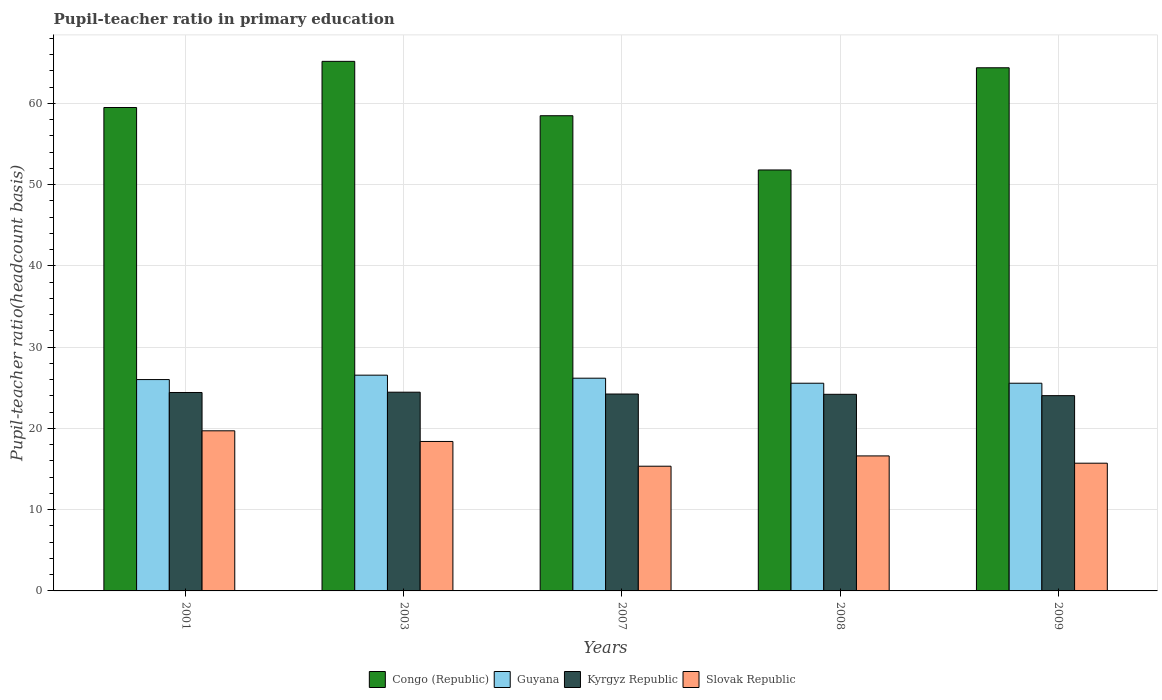Are the number of bars per tick equal to the number of legend labels?
Provide a succinct answer. Yes. In how many cases, is the number of bars for a given year not equal to the number of legend labels?
Your answer should be compact. 0. What is the pupil-teacher ratio in primary education in Guyana in 2001?
Make the answer very short. 26.01. Across all years, what is the maximum pupil-teacher ratio in primary education in Kyrgyz Republic?
Ensure brevity in your answer.  24.46. Across all years, what is the minimum pupil-teacher ratio in primary education in Slovak Republic?
Ensure brevity in your answer.  15.35. In which year was the pupil-teacher ratio in primary education in Congo (Republic) minimum?
Your answer should be compact. 2008. What is the total pupil-teacher ratio in primary education in Slovak Republic in the graph?
Make the answer very short. 85.78. What is the difference between the pupil-teacher ratio in primary education in Slovak Republic in 2003 and that in 2009?
Ensure brevity in your answer.  2.67. What is the difference between the pupil-teacher ratio in primary education in Congo (Republic) in 2008 and the pupil-teacher ratio in primary education in Slovak Republic in 2001?
Your response must be concise. 32.1. What is the average pupil-teacher ratio in primary education in Slovak Republic per year?
Your response must be concise. 17.16. In the year 2003, what is the difference between the pupil-teacher ratio in primary education in Guyana and pupil-teacher ratio in primary education in Kyrgyz Republic?
Keep it short and to the point. 2.1. What is the ratio of the pupil-teacher ratio in primary education in Guyana in 2007 to that in 2009?
Offer a very short reply. 1.02. Is the pupil-teacher ratio in primary education in Congo (Republic) in 2001 less than that in 2007?
Your response must be concise. No. What is the difference between the highest and the second highest pupil-teacher ratio in primary education in Kyrgyz Republic?
Your answer should be compact. 0.04. What is the difference between the highest and the lowest pupil-teacher ratio in primary education in Congo (Republic)?
Make the answer very short. 13.37. In how many years, is the pupil-teacher ratio in primary education in Congo (Republic) greater than the average pupil-teacher ratio in primary education in Congo (Republic) taken over all years?
Your answer should be compact. 2. Is the sum of the pupil-teacher ratio in primary education in Guyana in 2003 and 2009 greater than the maximum pupil-teacher ratio in primary education in Kyrgyz Republic across all years?
Your answer should be compact. Yes. What does the 4th bar from the left in 2003 represents?
Provide a succinct answer. Slovak Republic. What does the 2nd bar from the right in 2009 represents?
Provide a short and direct response. Kyrgyz Republic. How many bars are there?
Provide a succinct answer. 20. Are all the bars in the graph horizontal?
Ensure brevity in your answer.  No. How many years are there in the graph?
Your answer should be compact. 5. Does the graph contain any zero values?
Your answer should be very brief. No. How many legend labels are there?
Provide a succinct answer. 4. What is the title of the graph?
Provide a short and direct response. Pupil-teacher ratio in primary education. What is the label or title of the X-axis?
Offer a very short reply. Years. What is the label or title of the Y-axis?
Your answer should be very brief. Pupil-teacher ratio(headcount basis). What is the Pupil-teacher ratio(headcount basis) in Congo (Republic) in 2001?
Your answer should be very brief. 59.49. What is the Pupil-teacher ratio(headcount basis) in Guyana in 2001?
Your response must be concise. 26.01. What is the Pupil-teacher ratio(headcount basis) in Kyrgyz Republic in 2001?
Give a very brief answer. 24.42. What is the Pupil-teacher ratio(headcount basis) of Slovak Republic in 2001?
Your answer should be compact. 19.7. What is the Pupil-teacher ratio(headcount basis) in Congo (Republic) in 2003?
Your answer should be compact. 65.17. What is the Pupil-teacher ratio(headcount basis) in Guyana in 2003?
Ensure brevity in your answer.  26.55. What is the Pupil-teacher ratio(headcount basis) of Kyrgyz Republic in 2003?
Your answer should be compact. 24.46. What is the Pupil-teacher ratio(headcount basis) of Slovak Republic in 2003?
Keep it short and to the point. 18.39. What is the Pupil-teacher ratio(headcount basis) in Congo (Republic) in 2007?
Your answer should be compact. 58.48. What is the Pupil-teacher ratio(headcount basis) in Guyana in 2007?
Your response must be concise. 26.18. What is the Pupil-teacher ratio(headcount basis) of Kyrgyz Republic in 2007?
Your answer should be very brief. 24.23. What is the Pupil-teacher ratio(headcount basis) in Slovak Republic in 2007?
Keep it short and to the point. 15.35. What is the Pupil-teacher ratio(headcount basis) in Congo (Republic) in 2008?
Offer a very short reply. 51.8. What is the Pupil-teacher ratio(headcount basis) of Guyana in 2008?
Provide a short and direct response. 25.56. What is the Pupil-teacher ratio(headcount basis) of Kyrgyz Republic in 2008?
Give a very brief answer. 24.2. What is the Pupil-teacher ratio(headcount basis) in Slovak Republic in 2008?
Keep it short and to the point. 16.61. What is the Pupil-teacher ratio(headcount basis) in Congo (Republic) in 2009?
Your response must be concise. 64.38. What is the Pupil-teacher ratio(headcount basis) in Guyana in 2009?
Your response must be concise. 25.56. What is the Pupil-teacher ratio(headcount basis) in Kyrgyz Republic in 2009?
Your answer should be compact. 24.03. What is the Pupil-teacher ratio(headcount basis) in Slovak Republic in 2009?
Make the answer very short. 15.72. Across all years, what is the maximum Pupil-teacher ratio(headcount basis) in Congo (Republic)?
Your response must be concise. 65.17. Across all years, what is the maximum Pupil-teacher ratio(headcount basis) in Guyana?
Give a very brief answer. 26.55. Across all years, what is the maximum Pupil-teacher ratio(headcount basis) of Kyrgyz Republic?
Offer a terse response. 24.46. Across all years, what is the maximum Pupil-teacher ratio(headcount basis) in Slovak Republic?
Ensure brevity in your answer.  19.7. Across all years, what is the minimum Pupil-teacher ratio(headcount basis) in Congo (Republic)?
Keep it short and to the point. 51.8. Across all years, what is the minimum Pupil-teacher ratio(headcount basis) of Guyana?
Give a very brief answer. 25.56. Across all years, what is the minimum Pupil-teacher ratio(headcount basis) in Kyrgyz Republic?
Ensure brevity in your answer.  24.03. Across all years, what is the minimum Pupil-teacher ratio(headcount basis) in Slovak Republic?
Give a very brief answer. 15.35. What is the total Pupil-teacher ratio(headcount basis) of Congo (Republic) in the graph?
Offer a terse response. 299.33. What is the total Pupil-teacher ratio(headcount basis) of Guyana in the graph?
Provide a succinct answer. 129.86. What is the total Pupil-teacher ratio(headcount basis) of Kyrgyz Republic in the graph?
Ensure brevity in your answer.  121.33. What is the total Pupil-teacher ratio(headcount basis) of Slovak Republic in the graph?
Ensure brevity in your answer.  85.78. What is the difference between the Pupil-teacher ratio(headcount basis) of Congo (Republic) in 2001 and that in 2003?
Give a very brief answer. -5.68. What is the difference between the Pupil-teacher ratio(headcount basis) in Guyana in 2001 and that in 2003?
Offer a very short reply. -0.54. What is the difference between the Pupil-teacher ratio(headcount basis) in Kyrgyz Republic in 2001 and that in 2003?
Your response must be concise. -0.04. What is the difference between the Pupil-teacher ratio(headcount basis) of Slovak Republic in 2001 and that in 2003?
Offer a very short reply. 1.31. What is the difference between the Pupil-teacher ratio(headcount basis) of Congo (Republic) in 2001 and that in 2007?
Provide a succinct answer. 1.01. What is the difference between the Pupil-teacher ratio(headcount basis) of Guyana in 2001 and that in 2007?
Provide a short and direct response. -0.17. What is the difference between the Pupil-teacher ratio(headcount basis) in Kyrgyz Republic in 2001 and that in 2007?
Offer a terse response. 0.19. What is the difference between the Pupil-teacher ratio(headcount basis) of Slovak Republic in 2001 and that in 2007?
Make the answer very short. 4.36. What is the difference between the Pupil-teacher ratio(headcount basis) of Congo (Republic) in 2001 and that in 2008?
Ensure brevity in your answer.  7.69. What is the difference between the Pupil-teacher ratio(headcount basis) of Guyana in 2001 and that in 2008?
Your answer should be very brief. 0.45. What is the difference between the Pupil-teacher ratio(headcount basis) in Kyrgyz Republic in 2001 and that in 2008?
Your response must be concise. 0.22. What is the difference between the Pupil-teacher ratio(headcount basis) in Slovak Republic in 2001 and that in 2008?
Make the answer very short. 3.09. What is the difference between the Pupil-teacher ratio(headcount basis) of Congo (Republic) in 2001 and that in 2009?
Keep it short and to the point. -4.89. What is the difference between the Pupil-teacher ratio(headcount basis) of Guyana in 2001 and that in 2009?
Your response must be concise. 0.45. What is the difference between the Pupil-teacher ratio(headcount basis) in Kyrgyz Republic in 2001 and that in 2009?
Your response must be concise. 0.39. What is the difference between the Pupil-teacher ratio(headcount basis) in Slovak Republic in 2001 and that in 2009?
Your answer should be compact. 3.98. What is the difference between the Pupil-teacher ratio(headcount basis) in Congo (Republic) in 2003 and that in 2007?
Provide a succinct answer. 6.69. What is the difference between the Pupil-teacher ratio(headcount basis) in Guyana in 2003 and that in 2007?
Your answer should be very brief. 0.37. What is the difference between the Pupil-teacher ratio(headcount basis) of Kyrgyz Republic in 2003 and that in 2007?
Provide a succinct answer. 0.22. What is the difference between the Pupil-teacher ratio(headcount basis) of Slovak Republic in 2003 and that in 2007?
Make the answer very short. 3.05. What is the difference between the Pupil-teacher ratio(headcount basis) of Congo (Republic) in 2003 and that in 2008?
Provide a succinct answer. 13.37. What is the difference between the Pupil-teacher ratio(headcount basis) of Guyana in 2003 and that in 2008?
Provide a succinct answer. 0.99. What is the difference between the Pupil-teacher ratio(headcount basis) of Kyrgyz Republic in 2003 and that in 2008?
Offer a terse response. 0.26. What is the difference between the Pupil-teacher ratio(headcount basis) of Slovak Republic in 2003 and that in 2008?
Give a very brief answer. 1.78. What is the difference between the Pupil-teacher ratio(headcount basis) in Congo (Republic) in 2003 and that in 2009?
Ensure brevity in your answer.  0.79. What is the difference between the Pupil-teacher ratio(headcount basis) of Guyana in 2003 and that in 2009?
Provide a succinct answer. 0.99. What is the difference between the Pupil-teacher ratio(headcount basis) in Kyrgyz Republic in 2003 and that in 2009?
Your answer should be very brief. 0.42. What is the difference between the Pupil-teacher ratio(headcount basis) of Slovak Republic in 2003 and that in 2009?
Keep it short and to the point. 2.67. What is the difference between the Pupil-teacher ratio(headcount basis) of Congo (Republic) in 2007 and that in 2008?
Your answer should be compact. 6.68. What is the difference between the Pupil-teacher ratio(headcount basis) of Guyana in 2007 and that in 2008?
Keep it short and to the point. 0.62. What is the difference between the Pupil-teacher ratio(headcount basis) in Kyrgyz Republic in 2007 and that in 2008?
Provide a short and direct response. 0.03. What is the difference between the Pupil-teacher ratio(headcount basis) of Slovak Republic in 2007 and that in 2008?
Offer a very short reply. -1.27. What is the difference between the Pupil-teacher ratio(headcount basis) in Congo (Republic) in 2007 and that in 2009?
Offer a very short reply. -5.9. What is the difference between the Pupil-teacher ratio(headcount basis) of Guyana in 2007 and that in 2009?
Offer a very short reply. 0.62. What is the difference between the Pupil-teacher ratio(headcount basis) in Kyrgyz Republic in 2007 and that in 2009?
Provide a short and direct response. 0.2. What is the difference between the Pupil-teacher ratio(headcount basis) in Slovak Republic in 2007 and that in 2009?
Give a very brief answer. -0.37. What is the difference between the Pupil-teacher ratio(headcount basis) in Congo (Republic) in 2008 and that in 2009?
Keep it short and to the point. -12.58. What is the difference between the Pupil-teacher ratio(headcount basis) of Guyana in 2008 and that in 2009?
Provide a succinct answer. -0. What is the difference between the Pupil-teacher ratio(headcount basis) of Kyrgyz Republic in 2008 and that in 2009?
Provide a succinct answer. 0.17. What is the difference between the Pupil-teacher ratio(headcount basis) in Slovak Republic in 2008 and that in 2009?
Offer a terse response. 0.89. What is the difference between the Pupil-teacher ratio(headcount basis) of Congo (Republic) in 2001 and the Pupil-teacher ratio(headcount basis) of Guyana in 2003?
Keep it short and to the point. 32.94. What is the difference between the Pupil-teacher ratio(headcount basis) of Congo (Republic) in 2001 and the Pupil-teacher ratio(headcount basis) of Kyrgyz Republic in 2003?
Offer a terse response. 35.04. What is the difference between the Pupil-teacher ratio(headcount basis) of Congo (Republic) in 2001 and the Pupil-teacher ratio(headcount basis) of Slovak Republic in 2003?
Keep it short and to the point. 41.1. What is the difference between the Pupil-teacher ratio(headcount basis) of Guyana in 2001 and the Pupil-teacher ratio(headcount basis) of Kyrgyz Republic in 2003?
Give a very brief answer. 1.55. What is the difference between the Pupil-teacher ratio(headcount basis) of Guyana in 2001 and the Pupil-teacher ratio(headcount basis) of Slovak Republic in 2003?
Your answer should be compact. 7.62. What is the difference between the Pupil-teacher ratio(headcount basis) of Kyrgyz Republic in 2001 and the Pupil-teacher ratio(headcount basis) of Slovak Republic in 2003?
Your response must be concise. 6.03. What is the difference between the Pupil-teacher ratio(headcount basis) in Congo (Republic) in 2001 and the Pupil-teacher ratio(headcount basis) in Guyana in 2007?
Your response must be concise. 33.31. What is the difference between the Pupil-teacher ratio(headcount basis) of Congo (Republic) in 2001 and the Pupil-teacher ratio(headcount basis) of Kyrgyz Republic in 2007?
Provide a succinct answer. 35.26. What is the difference between the Pupil-teacher ratio(headcount basis) in Congo (Republic) in 2001 and the Pupil-teacher ratio(headcount basis) in Slovak Republic in 2007?
Offer a very short reply. 44.15. What is the difference between the Pupil-teacher ratio(headcount basis) of Guyana in 2001 and the Pupil-teacher ratio(headcount basis) of Kyrgyz Republic in 2007?
Offer a terse response. 1.78. What is the difference between the Pupil-teacher ratio(headcount basis) of Guyana in 2001 and the Pupil-teacher ratio(headcount basis) of Slovak Republic in 2007?
Your response must be concise. 10.66. What is the difference between the Pupil-teacher ratio(headcount basis) in Kyrgyz Republic in 2001 and the Pupil-teacher ratio(headcount basis) in Slovak Republic in 2007?
Offer a terse response. 9.07. What is the difference between the Pupil-teacher ratio(headcount basis) in Congo (Republic) in 2001 and the Pupil-teacher ratio(headcount basis) in Guyana in 2008?
Give a very brief answer. 33.93. What is the difference between the Pupil-teacher ratio(headcount basis) of Congo (Republic) in 2001 and the Pupil-teacher ratio(headcount basis) of Kyrgyz Republic in 2008?
Provide a short and direct response. 35.29. What is the difference between the Pupil-teacher ratio(headcount basis) in Congo (Republic) in 2001 and the Pupil-teacher ratio(headcount basis) in Slovak Republic in 2008?
Give a very brief answer. 42.88. What is the difference between the Pupil-teacher ratio(headcount basis) of Guyana in 2001 and the Pupil-teacher ratio(headcount basis) of Kyrgyz Republic in 2008?
Provide a succinct answer. 1.81. What is the difference between the Pupil-teacher ratio(headcount basis) in Guyana in 2001 and the Pupil-teacher ratio(headcount basis) in Slovak Republic in 2008?
Your response must be concise. 9.4. What is the difference between the Pupil-teacher ratio(headcount basis) in Kyrgyz Republic in 2001 and the Pupil-teacher ratio(headcount basis) in Slovak Republic in 2008?
Make the answer very short. 7.8. What is the difference between the Pupil-teacher ratio(headcount basis) in Congo (Republic) in 2001 and the Pupil-teacher ratio(headcount basis) in Guyana in 2009?
Keep it short and to the point. 33.93. What is the difference between the Pupil-teacher ratio(headcount basis) in Congo (Republic) in 2001 and the Pupil-teacher ratio(headcount basis) in Kyrgyz Republic in 2009?
Offer a terse response. 35.46. What is the difference between the Pupil-teacher ratio(headcount basis) in Congo (Republic) in 2001 and the Pupil-teacher ratio(headcount basis) in Slovak Republic in 2009?
Offer a terse response. 43.77. What is the difference between the Pupil-teacher ratio(headcount basis) in Guyana in 2001 and the Pupil-teacher ratio(headcount basis) in Kyrgyz Republic in 2009?
Give a very brief answer. 1.98. What is the difference between the Pupil-teacher ratio(headcount basis) in Guyana in 2001 and the Pupil-teacher ratio(headcount basis) in Slovak Republic in 2009?
Offer a terse response. 10.29. What is the difference between the Pupil-teacher ratio(headcount basis) in Kyrgyz Republic in 2001 and the Pupil-teacher ratio(headcount basis) in Slovak Republic in 2009?
Offer a terse response. 8.7. What is the difference between the Pupil-teacher ratio(headcount basis) of Congo (Republic) in 2003 and the Pupil-teacher ratio(headcount basis) of Guyana in 2007?
Your answer should be very brief. 38.99. What is the difference between the Pupil-teacher ratio(headcount basis) in Congo (Republic) in 2003 and the Pupil-teacher ratio(headcount basis) in Kyrgyz Republic in 2007?
Offer a very short reply. 40.94. What is the difference between the Pupil-teacher ratio(headcount basis) in Congo (Republic) in 2003 and the Pupil-teacher ratio(headcount basis) in Slovak Republic in 2007?
Your response must be concise. 49.82. What is the difference between the Pupil-teacher ratio(headcount basis) in Guyana in 2003 and the Pupil-teacher ratio(headcount basis) in Kyrgyz Republic in 2007?
Keep it short and to the point. 2.32. What is the difference between the Pupil-teacher ratio(headcount basis) of Guyana in 2003 and the Pupil-teacher ratio(headcount basis) of Slovak Republic in 2007?
Make the answer very short. 11.21. What is the difference between the Pupil-teacher ratio(headcount basis) of Kyrgyz Republic in 2003 and the Pupil-teacher ratio(headcount basis) of Slovak Republic in 2007?
Ensure brevity in your answer.  9.11. What is the difference between the Pupil-teacher ratio(headcount basis) in Congo (Republic) in 2003 and the Pupil-teacher ratio(headcount basis) in Guyana in 2008?
Your response must be concise. 39.61. What is the difference between the Pupil-teacher ratio(headcount basis) of Congo (Republic) in 2003 and the Pupil-teacher ratio(headcount basis) of Kyrgyz Republic in 2008?
Offer a terse response. 40.97. What is the difference between the Pupil-teacher ratio(headcount basis) in Congo (Republic) in 2003 and the Pupil-teacher ratio(headcount basis) in Slovak Republic in 2008?
Your response must be concise. 48.56. What is the difference between the Pupil-teacher ratio(headcount basis) of Guyana in 2003 and the Pupil-teacher ratio(headcount basis) of Kyrgyz Republic in 2008?
Ensure brevity in your answer.  2.35. What is the difference between the Pupil-teacher ratio(headcount basis) in Guyana in 2003 and the Pupil-teacher ratio(headcount basis) in Slovak Republic in 2008?
Your response must be concise. 9.94. What is the difference between the Pupil-teacher ratio(headcount basis) of Kyrgyz Republic in 2003 and the Pupil-teacher ratio(headcount basis) of Slovak Republic in 2008?
Provide a short and direct response. 7.84. What is the difference between the Pupil-teacher ratio(headcount basis) in Congo (Republic) in 2003 and the Pupil-teacher ratio(headcount basis) in Guyana in 2009?
Offer a terse response. 39.61. What is the difference between the Pupil-teacher ratio(headcount basis) of Congo (Republic) in 2003 and the Pupil-teacher ratio(headcount basis) of Kyrgyz Republic in 2009?
Ensure brevity in your answer.  41.14. What is the difference between the Pupil-teacher ratio(headcount basis) in Congo (Republic) in 2003 and the Pupil-teacher ratio(headcount basis) in Slovak Republic in 2009?
Keep it short and to the point. 49.45. What is the difference between the Pupil-teacher ratio(headcount basis) in Guyana in 2003 and the Pupil-teacher ratio(headcount basis) in Kyrgyz Republic in 2009?
Give a very brief answer. 2.52. What is the difference between the Pupil-teacher ratio(headcount basis) in Guyana in 2003 and the Pupil-teacher ratio(headcount basis) in Slovak Republic in 2009?
Your response must be concise. 10.83. What is the difference between the Pupil-teacher ratio(headcount basis) of Kyrgyz Republic in 2003 and the Pupil-teacher ratio(headcount basis) of Slovak Republic in 2009?
Offer a very short reply. 8.74. What is the difference between the Pupil-teacher ratio(headcount basis) in Congo (Republic) in 2007 and the Pupil-teacher ratio(headcount basis) in Guyana in 2008?
Offer a very short reply. 32.92. What is the difference between the Pupil-teacher ratio(headcount basis) of Congo (Republic) in 2007 and the Pupil-teacher ratio(headcount basis) of Kyrgyz Republic in 2008?
Keep it short and to the point. 34.28. What is the difference between the Pupil-teacher ratio(headcount basis) of Congo (Republic) in 2007 and the Pupil-teacher ratio(headcount basis) of Slovak Republic in 2008?
Your answer should be compact. 41.87. What is the difference between the Pupil-teacher ratio(headcount basis) in Guyana in 2007 and the Pupil-teacher ratio(headcount basis) in Kyrgyz Republic in 2008?
Your answer should be very brief. 1.98. What is the difference between the Pupil-teacher ratio(headcount basis) in Guyana in 2007 and the Pupil-teacher ratio(headcount basis) in Slovak Republic in 2008?
Your response must be concise. 9.56. What is the difference between the Pupil-teacher ratio(headcount basis) of Kyrgyz Republic in 2007 and the Pupil-teacher ratio(headcount basis) of Slovak Republic in 2008?
Keep it short and to the point. 7.62. What is the difference between the Pupil-teacher ratio(headcount basis) in Congo (Republic) in 2007 and the Pupil-teacher ratio(headcount basis) in Guyana in 2009?
Provide a succinct answer. 32.92. What is the difference between the Pupil-teacher ratio(headcount basis) of Congo (Republic) in 2007 and the Pupil-teacher ratio(headcount basis) of Kyrgyz Republic in 2009?
Provide a short and direct response. 34.45. What is the difference between the Pupil-teacher ratio(headcount basis) in Congo (Republic) in 2007 and the Pupil-teacher ratio(headcount basis) in Slovak Republic in 2009?
Your response must be concise. 42.76. What is the difference between the Pupil-teacher ratio(headcount basis) in Guyana in 2007 and the Pupil-teacher ratio(headcount basis) in Kyrgyz Republic in 2009?
Give a very brief answer. 2.15. What is the difference between the Pupil-teacher ratio(headcount basis) in Guyana in 2007 and the Pupil-teacher ratio(headcount basis) in Slovak Republic in 2009?
Offer a terse response. 10.46. What is the difference between the Pupil-teacher ratio(headcount basis) of Kyrgyz Republic in 2007 and the Pupil-teacher ratio(headcount basis) of Slovak Republic in 2009?
Your answer should be compact. 8.51. What is the difference between the Pupil-teacher ratio(headcount basis) in Congo (Republic) in 2008 and the Pupil-teacher ratio(headcount basis) in Guyana in 2009?
Your answer should be very brief. 26.24. What is the difference between the Pupil-teacher ratio(headcount basis) of Congo (Republic) in 2008 and the Pupil-teacher ratio(headcount basis) of Kyrgyz Republic in 2009?
Make the answer very short. 27.77. What is the difference between the Pupil-teacher ratio(headcount basis) of Congo (Republic) in 2008 and the Pupil-teacher ratio(headcount basis) of Slovak Republic in 2009?
Ensure brevity in your answer.  36.09. What is the difference between the Pupil-teacher ratio(headcount basis) of Guyana in 2008 and the Pupil-teacher ratio(headcount basis) of Kyrgyz Republic in 2009?
Your answer should be very brief. 1.53. What is the difference between the Pupil-teacher ratio(headcount basis) of Guyana in 2008 and the Pupil-teacher ratio(headcount basis) of Slovak Republic in 2009?
Make the answer very short. 9.84. What is the difference between the Pupil-teacher ratio(headcount basis) of Kyrgyz Republic in 2008 and the Pupil-teacher ratio(headcount basis) of Slovak Republic in 2009?
Make the answer very short. 8.48. What is the average Pupil-teacher ratio(headcount basis) of Congo (Republic) per year?
Your answer should be compact. 59.87. What is the average Pupil-teacher ratio(headcount basis) of Guyana per year?
Offer a very short reply. 25.97. What is the average Pupil-teacher ratio(headcount basis) of Kyrgyz Republic per year?
Provide a succinct answer. 24.27. What is the average Pupil-teacher ratio(headcount basis) in Slovak Republic per year?
Your answer should be very brief. 17.16. In the year 2001, what is the difference between the Pupil-teacher ratio(headcount basis) in Congo (Republic) and Pupil-teacher ratio(headcount basis) in Guyana?
Offer a terse response. 33.48. In the year 2001, what is the difference between the Pupil-teacher ratio(headcount basis) of Congo (Republic) and Pupil-teacher ratio(headcount basis) of Kyrgyz Republic?
Your response must be concise. 35.07. In the year 2001, what is the difference between the Pupil-teacher ratio(headcount basis) of Congo (Republic) and Pupil-teacher ratio(headcount basis) of Slovak Republic?
Your answer should be compact. 39.79. In the year 2001, what is the difference between the Pupil-teacher ratio(headcount basis) of Guyana and Pupil-teacher ratio(headcount basis) of Kyrgyz Republic?
Keep it short and to the point. 1.59. In the year 2001, what is the difference between the Pupil-teacher ratio(headcount basis) in Guyana and Pupil-teacher ratio(headcount basis) in Slovak Republic?
Offer a terse response. 6.31. In the year 2001, what is the difference between the Pupil-teacher ratio(headcount basis) in Kyrgyz Republic and Pupil-teacher ratio(headcount basis) in Slovak Republic?
Keep it short and to the point. 4.71. In the year 2003, what is the difference between the Pupil-teacher ratio(headcount basis) in Congo (Republic) and Pupil-teacher ratio(headcount basis) in Guyana?
Your answer should be compact. 38.62. In the year 2003, what is the difference between the Pupil-teacher ratio(headcount basis) in Congo (Republic) and Pupil-teacher ratio(headcount basis) in Kyrgyz Republic?
Ensure brevity in your answer.  40.72. In the year 2003, what is the difference between the Pupil-teacher ratio(headcount basis) of Congo (Republic) and Pupil-teacher ratio(headcount basis) of Slovak Republic?
Give a very brief answer. 46.78. In the year 2003, what is the difference between the Pupil-teacher ratio(headcount basis) of Guyana and Pupil-teacher ratio(headcount basis) of Kyrgyz Republic?
Provide a succinct answer. 2.1. In the year 2003, what is the difference between the Pupil-teacher ratio(headcount basis) of Guyana and Pupil-teacher ratio(headcount basis) of Slovak Republic?
Your answer should be very brief. 8.16. In the year 2003, what is the difference between the Pupil-teacher ratio(headcount basis) in Kyrgyz Republic and Pupil-teacher ratio(headcount basis) in Slovak Republic?
Offer a terse response. 6.06. In the year 2007, what is the difference between the Pupil-teacher ratio(headcount basis) of Congo (Republic) and Pupil-teacher ratio(headcount basis) of Guyana?
Your response must be concise. 32.3. In the year 2007, what is the difference between the Pupil-teacher ratio(headcount basis) in Congo (Republic) and Pupil-teacher ratio(headcount basis) in Kyrgyz Republic?
Provide a succinct answer. 34.25. In the year 2007, what is the difference between the Pupil-teacher ratio(headcount basis) of Congo (Republic) and Pupil-teacher ratio(headcount basis) of Slovak Republic?
Offer a terse response. 43.13. In the year 2007, what is the difference between the Pupil-teacher ratio(headcount basis) in Guyana and Pupil-teacher ratio(headcount basis) in Kyrgyz Republic?
Provide a short and direct response. 1.95. In the year 2007, what is the difference between the Pupil-teacher ratio(headcount basis) in Guyana and Pupil-teacher ratio(headcount basis) in Slovak Republic?
Your answer should be very brief. 10.83. In the year 2007, what is the difference between the Pupil-teacher ratio(headcount basis) of Kyrgyz Republic and Pupil-teacher ratio(headcount basis) of Slovak Republic?
Provide a short and direct response. 8.88. In the year 2008, what is the difference between the Pupil-teacher ratio(headcount basis) of Congo (Republic) and Pupil-teacher ratio(headcount basis) of Guyana?
Offer a terse response. 26.24. In the year 2008, what is the difference between the Pupil-teacher ratio(headcount basis) of Congo (Republic) and Pupil-teacher ratio(headcount basis) of Kyrgyz Republic?
Your response must be concise. 27.61. In the year 2008, what is the difference between the Pupil-teacher ratio(headcount basis) of Congo (Republic) and Pupil-teacher ratio(headcount basis) of Slovak Republic?
Keep it short and to the point. 35.19. In the year 2008, what is the difference between the Pupil-teacher ratio(headcount basis) of Guyana and Pupil-teacher ratio(headcount basis) of Kyrgyz Republic?
Offer a very short reply. 1.36. In the year 2008, what is the difference between the Pupil-teacher ratio(headcount basis) of Guyana and Pupil-teacher ratio(headcount basis) of Slovak Republic?
Provide a succinct answer. 8.95. In the year 2008, what is the difference between the Pupil-teacher ratio(headcount basis) of Kyrgyz Republic and Pupil-teacher ratio(headcount basis) of Slovak Republic?
Offer a very short reply. 7.58. In the year 2009, what is the difference between the Pupil-teacher ratio(headcount basis) of Congo (Republic) and Pupil-teacher ratio(headcount basis) of Guyana?
Ensure brevity in your answer.  38.82. In the year 2009, what is the difference between the Pupil-teacher ratio(headcount basis) in Congo (Republic) and Pupil-teacher ratio(headcount basis) in Kyrgyz Republic?
Ensure brevity in your answer.  40.35. In the year 2009, what is the difference between the Pupil-teacher ratio(headcount basis) of Congo (Republic) and Pupil-teacher ratio(headcount basis) of Slovak Republic?
Your response must be concise. 48.66. In the year 2009, what is the difference between the Pupil-teacher ratio(headcount basis) of Guyana and Pupil-teacher ratio(headcount basis) of Kyrgyz Republic?
Your answer should be very brief. 1.53. In the year 2009, what is the difference between the Pupil-teacher ratio(headcount basis) of Guyana and Pupil-teacher ratio(headcount basis) of Slovak Republic?
Offer a terse response. 9.84. In the year 2009, what is the difference between the Pupil-teacher ratio(headcount basis) of Kyrgyz Republic and Pupil-teacher ratio(headcount basis) of Slovak Republic?
Your response must be concise. 8.31. What is the ratio of the Pupil-teacher ratio(headcount basis) in Congo (Republic) in 2001 to that in 2003?
Offer a terse response. 0.91. What is the ratio of the Pupil-teacher ratio(headcount basis) in Guyana in 2001 to that in 2003?
Your response must be concise. 0.98. What is the ratio of the Pupil-teacher ratio(headcount basis) of Slovak Republic in 2001 to that in 2003?
Provide a succinct answer. 1.07. What is the ratio of the Pupil-teacher ratio(headcount basis) in Congo (Republic) in 2001 to that in 2007?
Offer a terse response. 1.02. What is the ratio of the Pupil-teacher ratio(headcount basis) in Kyrgyz Republic in 2001 to that in 2007?
Your answer should be compact. 1.01. What is the ratio of the Pupil-teacher ratio(headcount basis) of Slovak Republic in 2001 to that in 2007?
Offer a terse response. 1.28. What is the ratio of the Pupil-teacher ratio(headcount basis) of Congo (Republic) in 2001 to that in 2008?
Your response must be concise. 1.15. What is the ratio of the Pupil-teacher ratio(headcount basis) in Guyana in 2001 to that in 2008?
Make the answer very short. 1.02. What is the ratio of the Pupil-teacher ratio(headcount basis) in Kyrgyz Republic in 2001 to that in 2008?
Ensure brevity in your answer.  1.01. What is the ratio of the Pupil-teacher ratio(headcount basis) in Slovak Republic in 2001 to that in 2008?
Give a very brief answer. 1.19. What is the ratio of the Pupil-teacher ratio(headcount basis) of Congo (Republic) in 2001 to that in 2009?
Provide a short and direct response. 0.92. What is the ratio of the Pupil-teacher ratio(headcount basis) in Guyana in 2001 to that in 2009?
Your answer should be compact. 1.02. What is the ratio of the Pupil-teacher ratio(headcount basis) of Kyrgyz Republic in 2001 to that in 2009?
Make the answer very short. 1.02. What is the ratio of the Pupil-teacher ratio(headcount basis) of Slovak Republic in 2001 to that in 2009?
Provide a short and direct response. 1.25. What is the ratio of the Pupil-teacher ratio(headcount basis) of Congo (Republic) in 2003 to that in 2007?
Give a very brief answer. 1.11. What is the ratio of the Pupil-teacher ratio(headcount basis) of Guyana in 2003 to that in 2007?
Give a very brief answer. 1.01. What is the ratio of the Pupil-teacher ratio(headcount basis) in Kyrgyz Republic in 2003 to that in 2007?
Your response must be concise. 1.01. What is the ratio of the Pupil-teacher ratio(headcount basis) of Slovak Republic in 2003 to that in 2007?
Offer a terse response. 1.2. What is the ratio of the Pupil-teacher ratio(headcount basis) in Congo (Republic) in 2003 to that in 2008?
Provide a short and direct response. 1.26. What is the ratio of the Pupil-teacher ratio(headcount basis) in Guyana in 2003 to that in 2008?
Offer a very short reply. 1.04. What is the ratio of the Pupil-teacher ratio(headcount basis) in Kyrgyz Republic in 2003 to that in 2008?
Make the answer very short. 1.01. What is the ratio of the Pupil-teacher ratio(headcount basis) of Slovak Republic in 2003 to that in 2008?
Give a very brief answer. 1.11. What is the ratio of the Pupil-teacher ratio(headcount basis) in Congo (Republic) in 2003 to that in 2009?
Give a very brief answer. 1.01. What is the ratio of the Pupil-teacher ratio(headcount basis) of Guyana in 2003 to that in 2009?
Offer a terse response. 1.04. What is the ratio of the Pupil-teacher ratio(headcount basis) in Kyrgyz Republic in 2003 to that in 2009?
Offer a very short reply. 1.02. What is the ratio of the Pupil-teacher ratio(headcount basis) in Slovak Republic in 2003 to that in 2009?
Offer a very short reply. 1.17. What is the ratio of the Pupil-teacher ratio(headcount basis) of Congo (Republic) in 2007 to that in 2008?
Keep it short and to the point. 1.13. What is the ratio of the Pupil-teacher ratio(headcount basis) of Guyana in 2007 to that in 2008?
Provide a succinct answer. 1.02. What is the ratio of the Pupil-teacher ratio(headcount basis) in Kyrgyz Republic in 2007 to that in 2008?
Your response must be concise. 1. What is the ratio of the Pupil-teacher ratio(headcount basis) of Slovak Republic in 2007 to that in 2008?
Offer a very short reply. 0.92. What is the ratio of the Pupil-teacher ratio(headcount basis) in Congo (Republic) in 2007 to that in 2009?
Offer a very short reply. 0.91. What is the ratio of the Pupil-teacher ratio(headcount basis) in Guyana in 2007 to that in 2009?
Provide a succinct answer. 1.02. What is the ratio of the Pupil-teacher ratio(headcount basis) of Kyrgyz Republic in 2007 to that in 2009?
Offer a terse response. 1.01. What is the ratio of the Pupil-teacher ratio(headcount basis) of Slovak Republic in 2007 to that in 2009?
Make the answer very short. 0.98. What is the ratio of the Pupil-teacher ratio(headcount basis) in Congo (Republic) in 2008 to that in 2009?
Offer a very short reply. 0.8. What is the ratio of the Pupil-teacher ratio(headcount basis) in Slovak Republic in 2008 to that in 2009?
Provide a short and direct response. 1.06. What is the difference between the highest and the second highest Pupil-teacher ratio(headcount basis) in Congo (Republic)?
Your response must be concise. 0.79. What is the difference between the highest and the second highest Pupil-teacher ratio(headcount basis) in Guyana?
Offer a terse response. 0.37. What is the difference between the highest and the second highest Pupil-teacher ratio(headcount basis) of Kyrgyz Republic?
Your answer should be compact. 0.04. What is the difference between the highest and the second highest Pupil-teacher ratio(headcount basis) in Slovak Republic?
Make the answer very short. 1.31. What is the difference between the highest and the lowest Pupil-teacher ratio(headcount basis) in Congo (Republic)?
Provide a succinct answer. 13.37. What is the difference between the highest and the lowest Pupil-teacher ratio(headcount basis) of Kyrgyz Republic?
Your response must be concise. 0.42. What is the difference between the highest and the lowest Pupil-teacher ratio(headcount basis) of Slovak Republic?
Give a very brief answer. 4.36. 